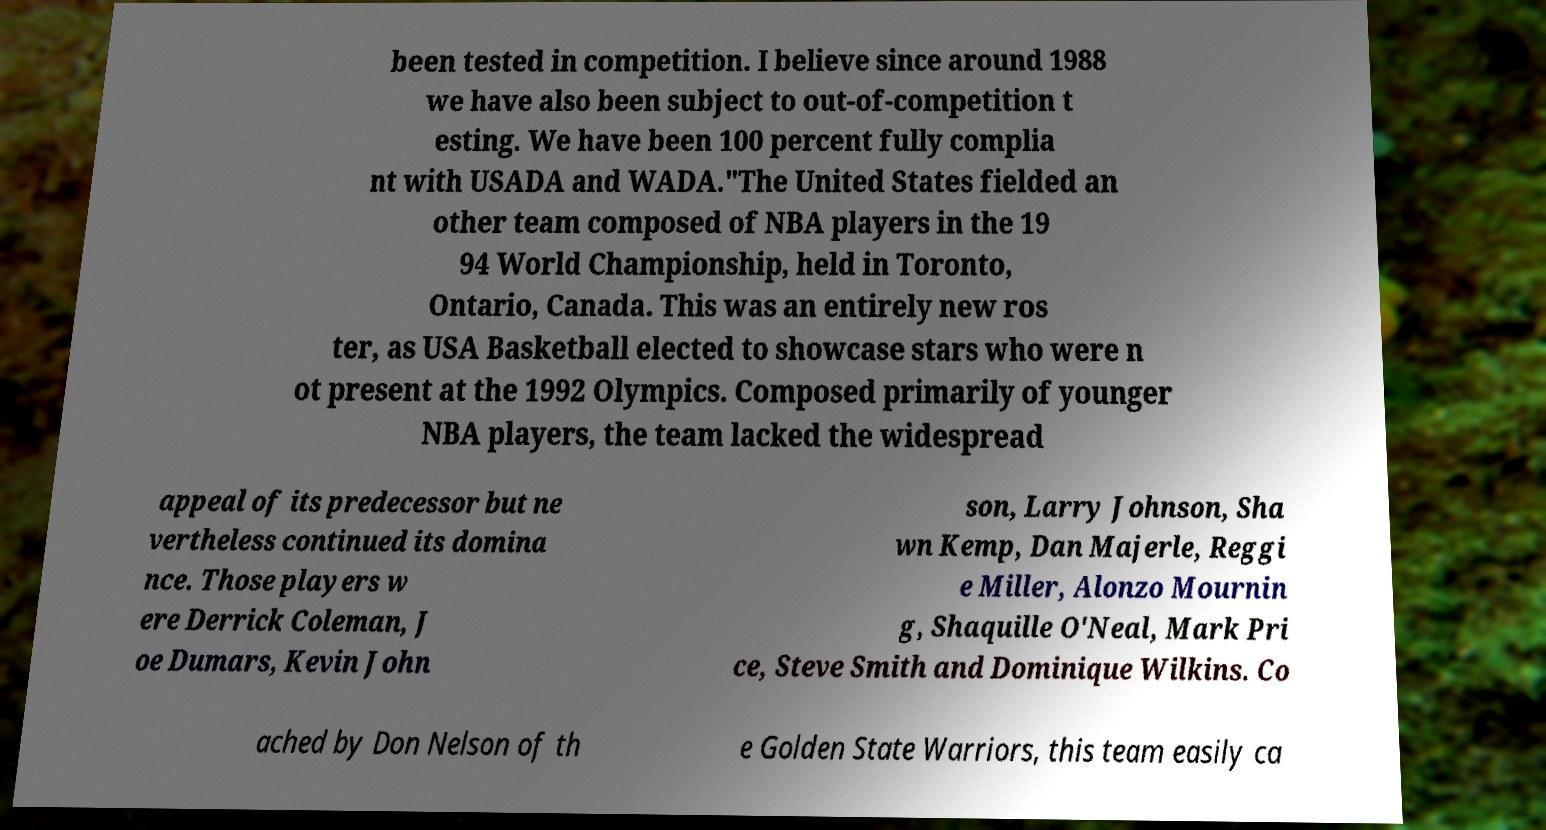For documentation purposes, I need the text within this image transcribed. Could you provide that? been tested in competition. I believe since around 1988 we have also been subject to out-of-competition t esting. We have been 100 percent fully complia nt with USADA and WADA."The United States fielded an other team composed of NBA players in the 19 94 World Championship, held in Toronto, Ontario, Canada. This was an entirely new ros ter, as USA Basketball elected to showcase stars who were n ot present at the 1992 Olympics. Composed primarily of younger NBA players, the team lacked the widespread appeal of its predecessor but ne vertheless continued its domina nce. Those players w ere Derrick Coleman, J oe Dumars, Kevin John son, Larry Johnson, Sha wn Kemp, Dan Majerle, Reggi e Miller, Alonzo Mournin g, Shaquille O'Neal, Mark Pri ce, Steve Smith and Dominique Wilkins. Co ached by Don Nelson of th e Golden State Warriors, this team easily ca 